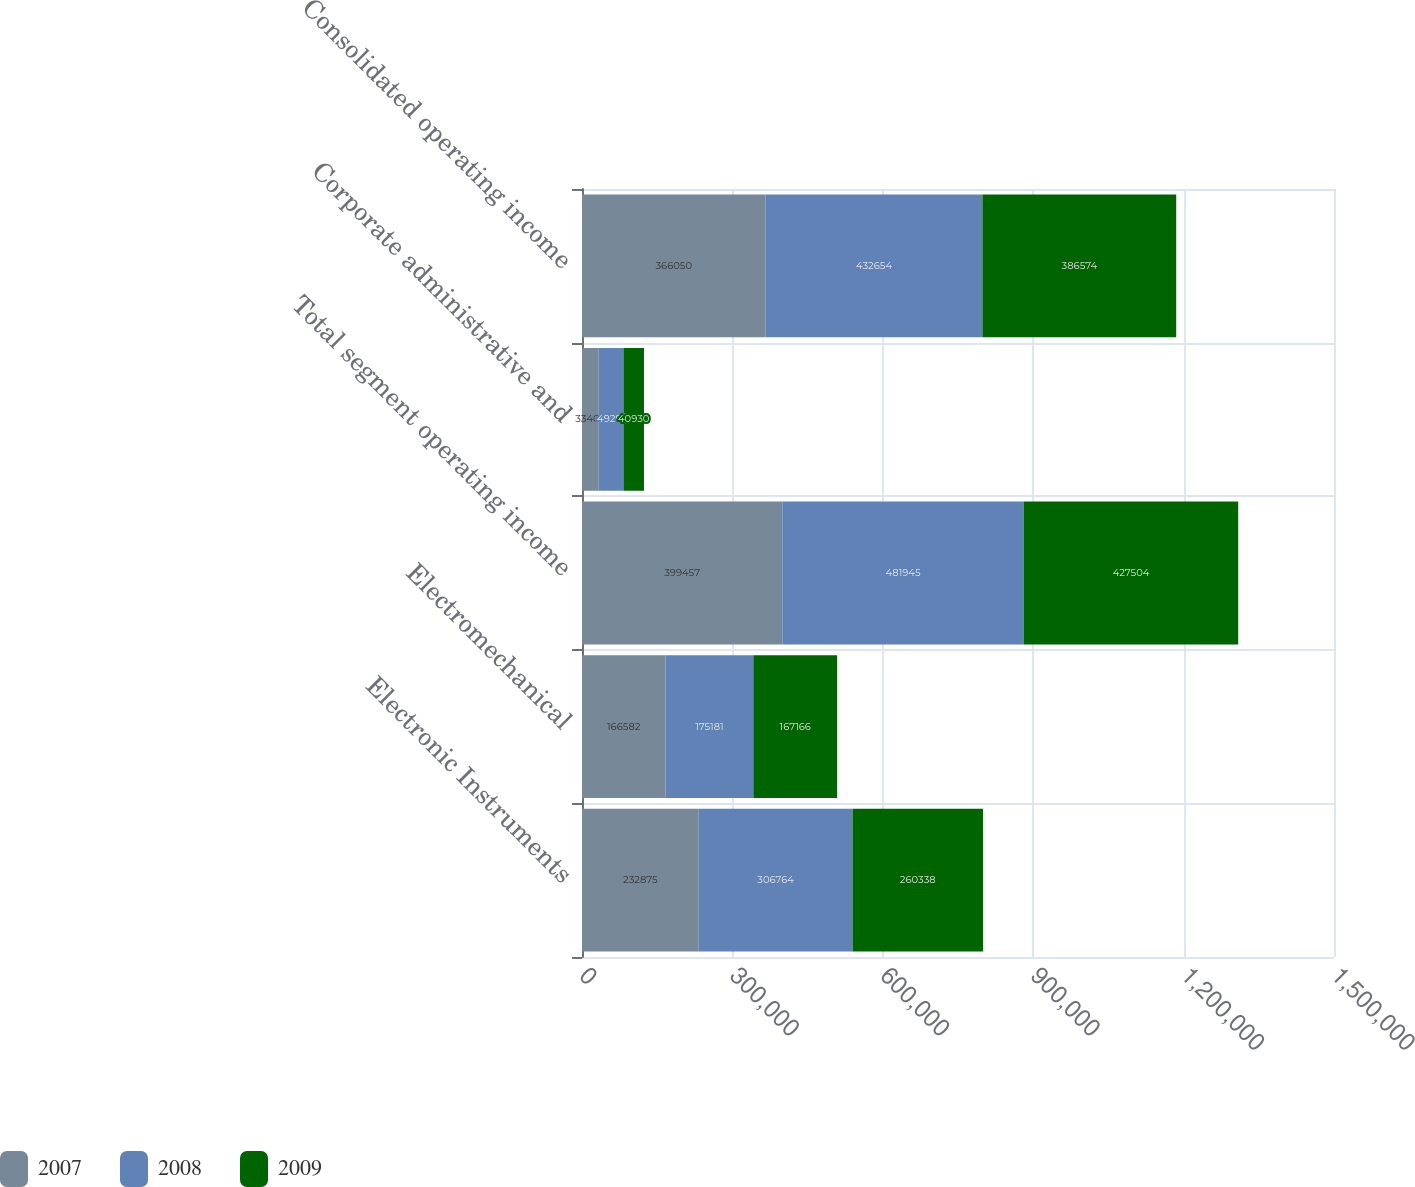Convert chart to OTSL. <chart><loc_0><loc_0><loc_500><loc_500><stacked_bar_chart><ecel><fcel>Electronic Instruments<fcel>Electromechanical<fcel>Total segment operating income<fcel>Corporate administrative and<fcel>Consolidated operating income<nl><fcel>2007<fcel>232875<fcel>166582<fcel>399457<fcel>33407<fcel>366050<nl><fcel>2008<fcel>306764<fcel>175181<fcel>481945<fcel>49291<fcel>432654<nl><fcel>2009<fcel>260338<fcel>167166<fcel>427504<fcel>40930<fcel>386574<nl></chart> 